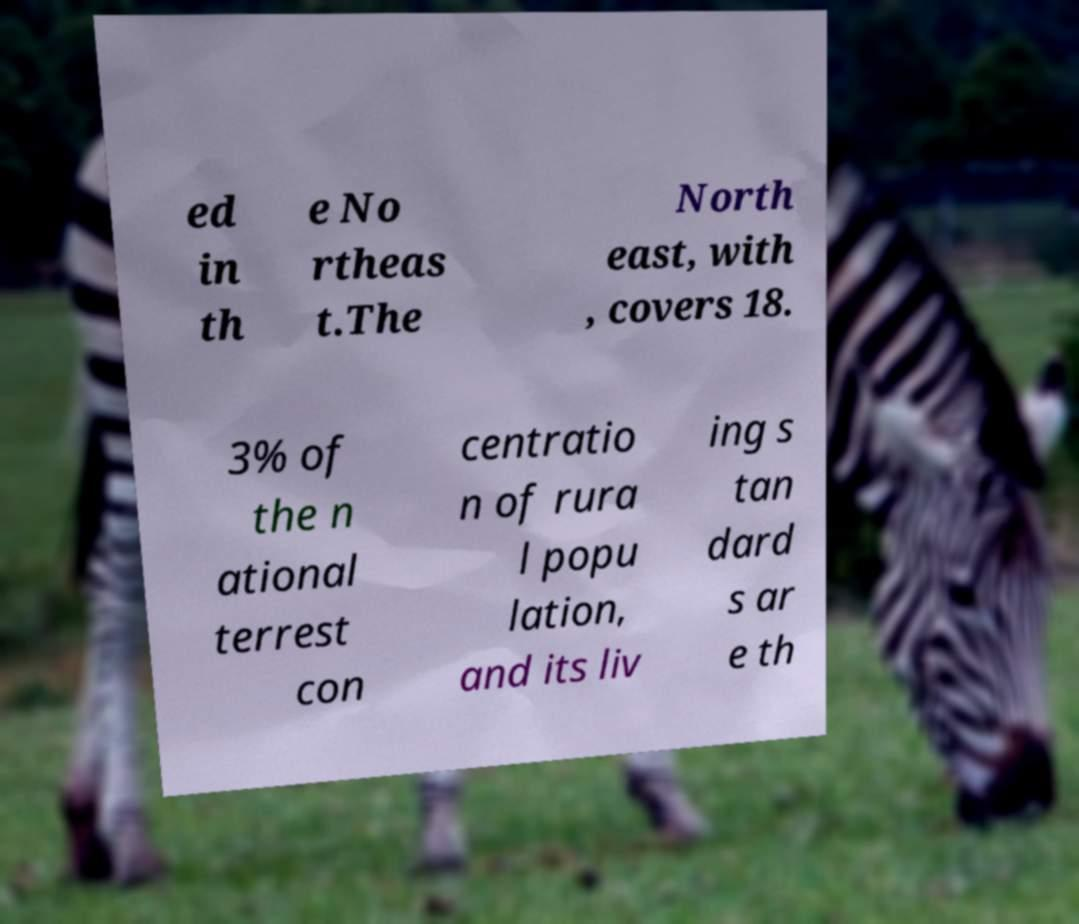I need the written content from this picture converted into text. Can you do that? ed in th e No rtheas t.The North east, with , covers 18. 3% of the n ational terrest con centratio n of rura l popu lation, and its liv ing s tan dard s ar e th 